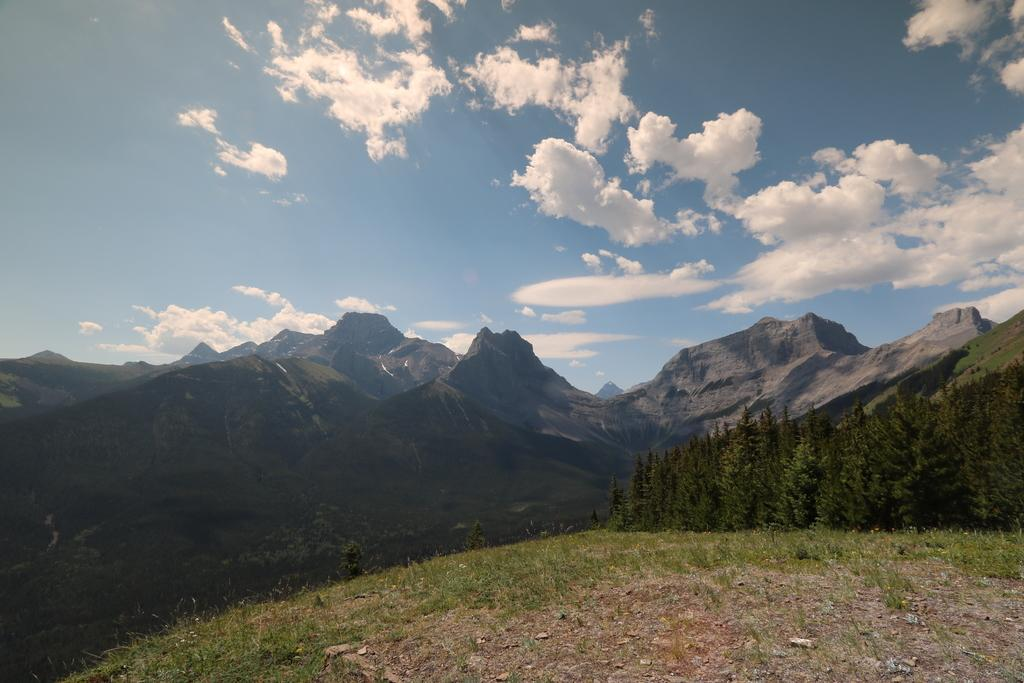What type of terrain is visible in the image? There is an open grass ground in the image. What natural elements can be seen on the grass ground? There are multiple trees on the grass ground. What can be seen in the distance behind the grass ground? Mountains are visible in the background, along with clouds and the sky. What type of religion is being practiced in the image? There is no indication of any religious practice or belief in the image. What type of quilt is being used to cover the grass ground in the image? There is no quilt present in the image; it features an open grass ground with trees. 